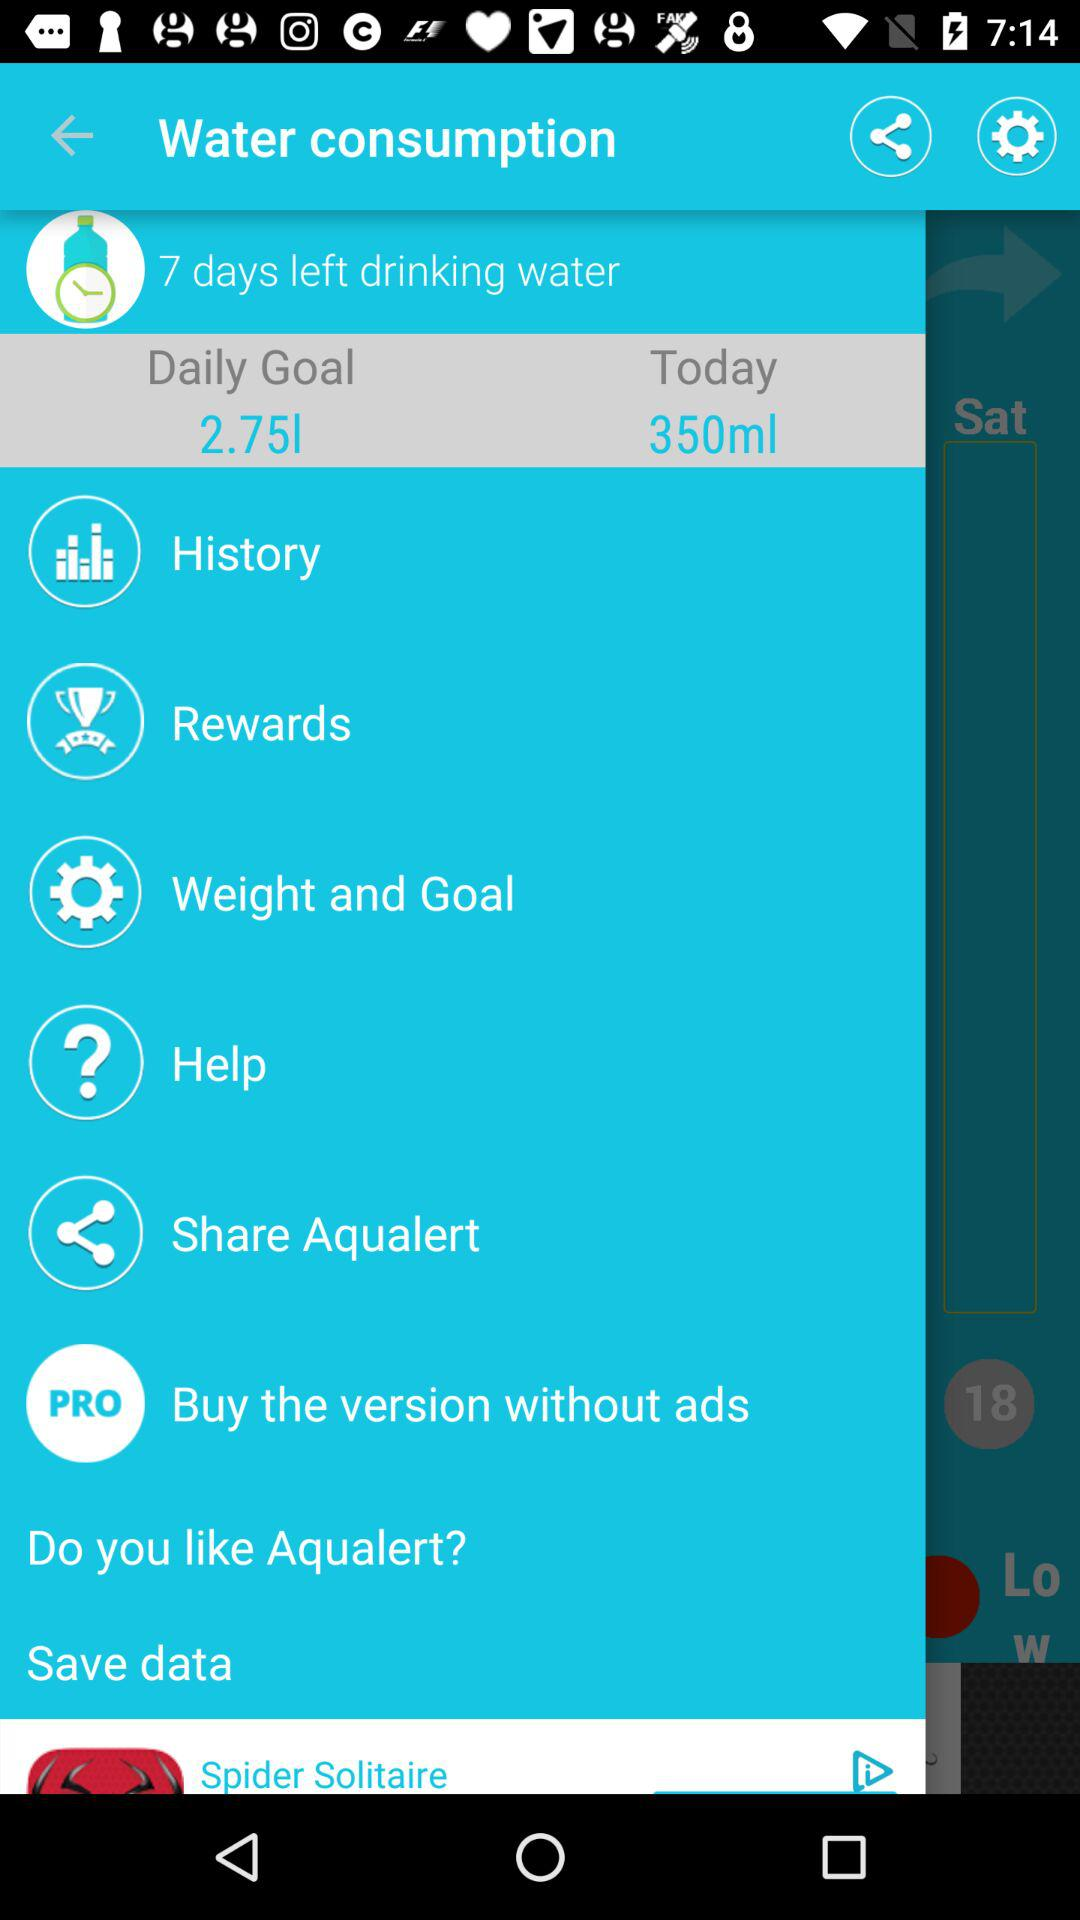How much water has been consumed today? Today, 350 ml of water has been consumed. 